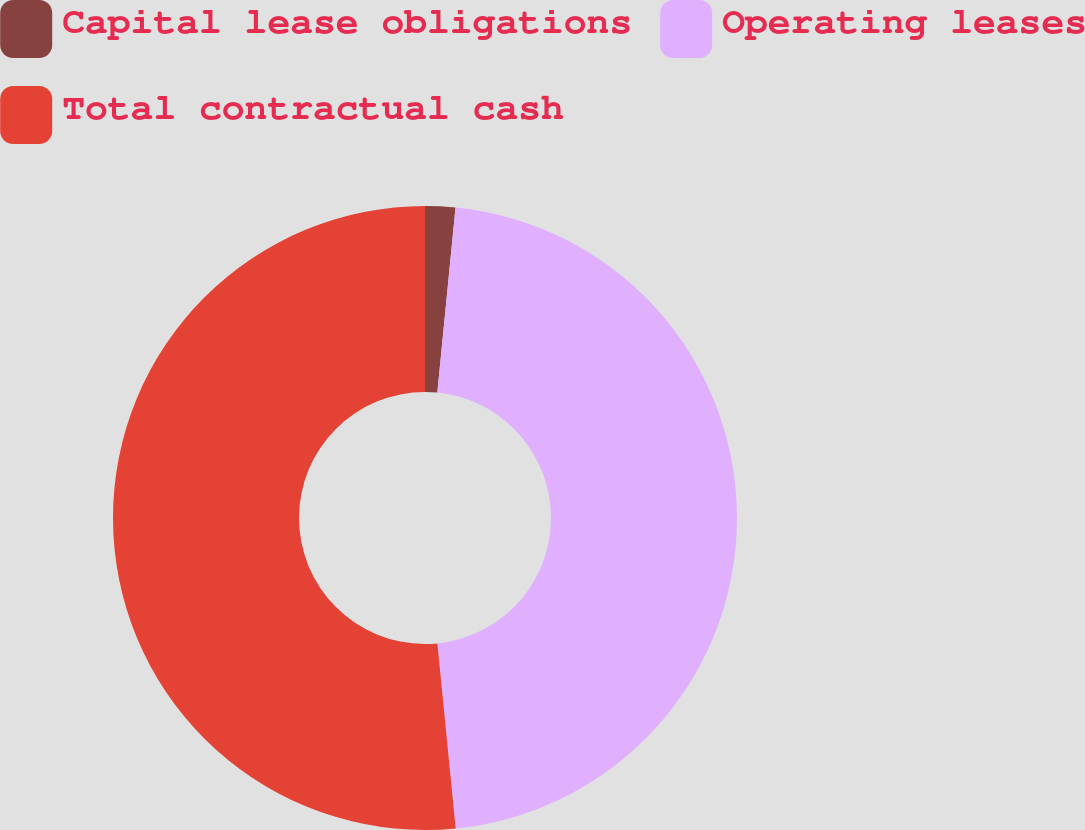Convert chart to OTSL. <chart><loc_0><loc_0><loc_500><loc_500><pie_chart><fcel>Capital lease obligations<fcel>Operating leases<fcel>Total contractual cash<nl><fcel>1.56%<fcel>46.87%<fcel>51.57%<nl></chart> 